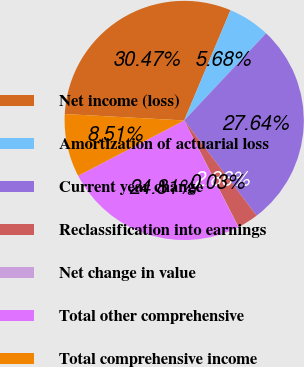<chart> <loc_0><loc_0><loc_500><loc_500><pie_chart><fcel>Net income (loss)<fcel>Amortization of actuarial loss<fcel>Current year change<fcel>Reclassification into earnings<fcel>Net change in value<fcel>Total other comprehensive<fcel>Total comprehensive income<nl><fcel>30.47%<fcel>5.68%<fcel>27.64%<fcel>2.86%<fcel>0.03%<fcel>24.81%<fcel>8.51%<nl></chart> 